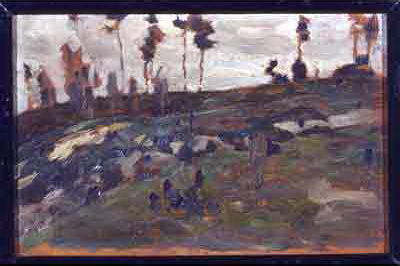What are the key elements in this picture?
 The image is an impressionist landscape painting that captures a rocky hillside adorned with trees and shrubs. The artist has used a palette dominated by dark and earthy colors, with occasional hints of blue and green adding depth and contrast. The brushstrokes are loose and expressive, a characteristic feature of the impressionist style, which adds a sense of movement and texture to the scene. The overall mood of the painting is somber and contemplative, reflecting the quiet beauty of nature. 